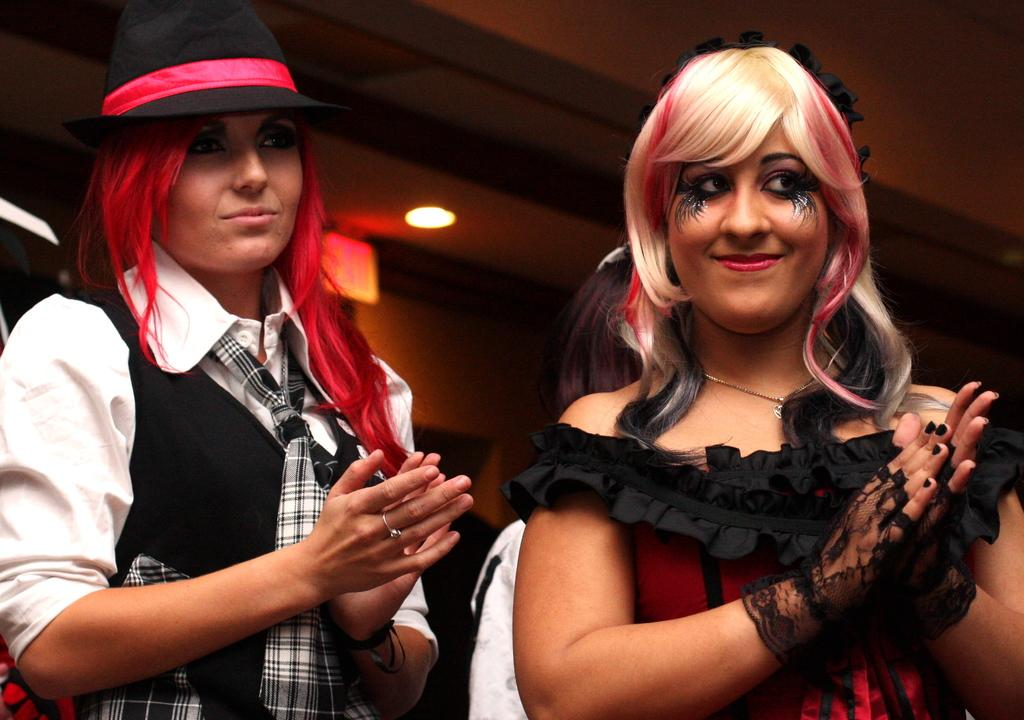How many people are in the image? There are two ladies in the image. What are the ladies wearing? The ladies are wearing costumes. Can you describe any other elements in the image? There is a light visible at the top of the image. What type of science experiment can be seen in the image? There is no science experiment present in the image; it features two ladies wearing costumes and a light visible at the top. Is there a coat visible in the image? There is no coat present in the image. 